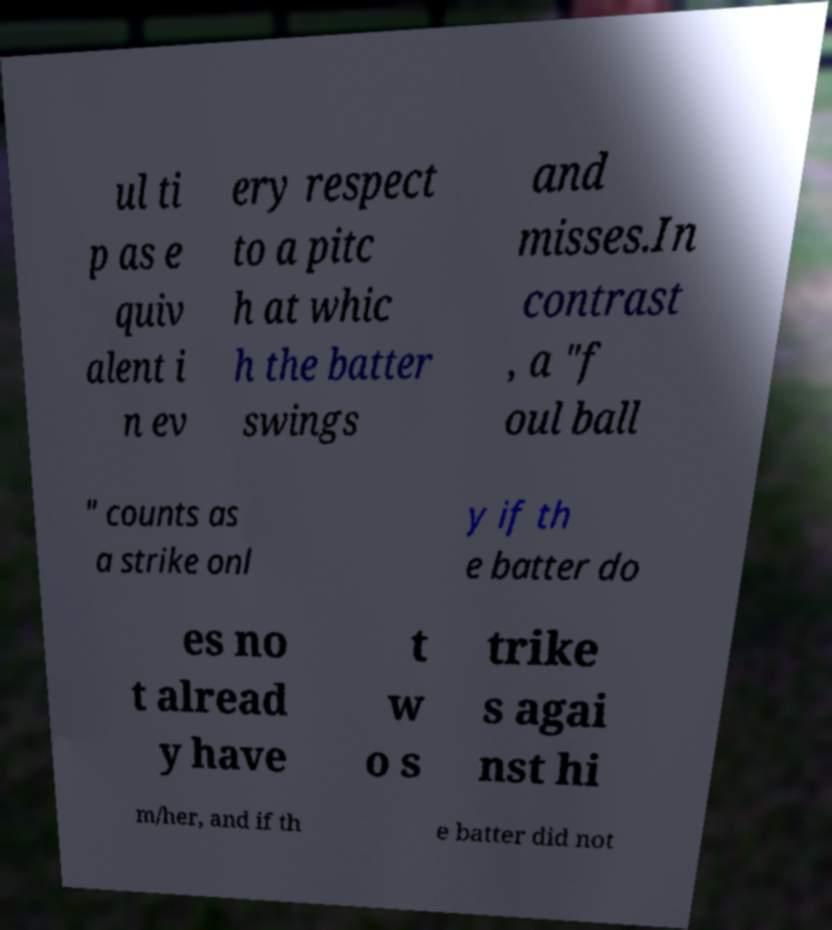There's text embedded in this image that I need extracted. Can you transcribe it verbatim? ul ti p as e quiv alent i n ev ery respect to a pitc h at whic h the batter swings and misses.In contrast , a "f oul ball " counts as a strike onl y if th e batter do es no t alread y have t w o s trike s agai nst hi m/her, and if th e batter did not 